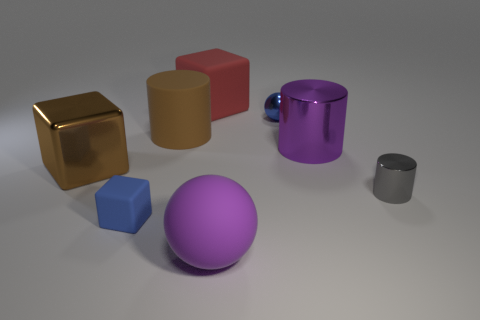Imagine these objects are part of a product design, what could they represent? These objects could represent a modern, minimalist set of desk ornaments, each with a practical function. The large golden cube could be a paperweight, the red rectangle a pen holder, the purple sphere a stress ball, the blue cube a sharpener, and the small gray cylinder could be a holder for paper clips. 